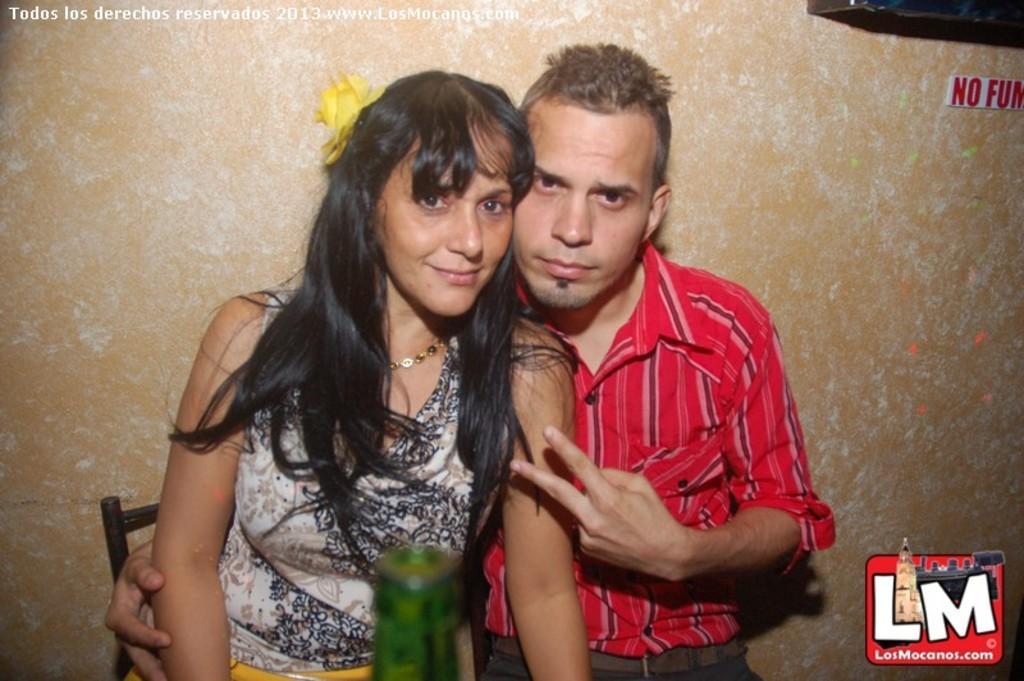In one or two sentences, can you explain what this image depicts? In this image we can see two people sitting on chairs. In-front of them there is a bottle. At the top left side of the image there is a watermark. At the bottom right side of the image there is a logo. In the background there is a wall and board.   